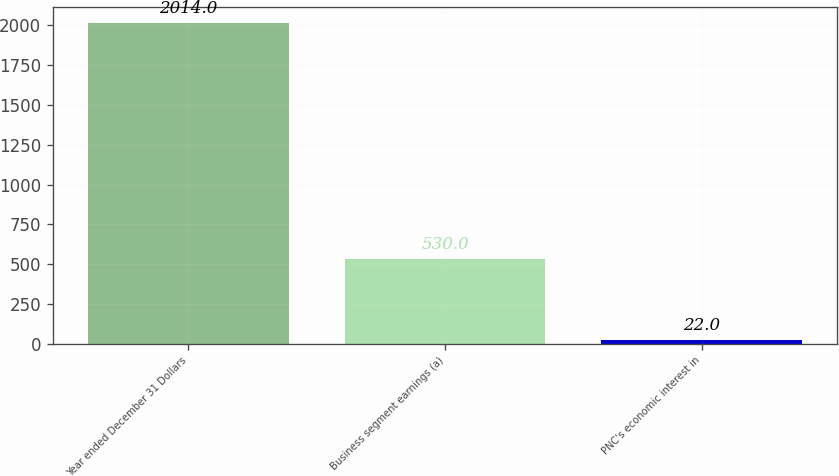<chart> <loc_0><loc_0><loc_500><loc_500><bar_chart><fcel>Year ended December 31 Dollars<fcel>Business segment earnings (a)<fcel>PNC's economic interest in<nl><fcel>2014<fcel>530<fcel>22<nl></chart> 